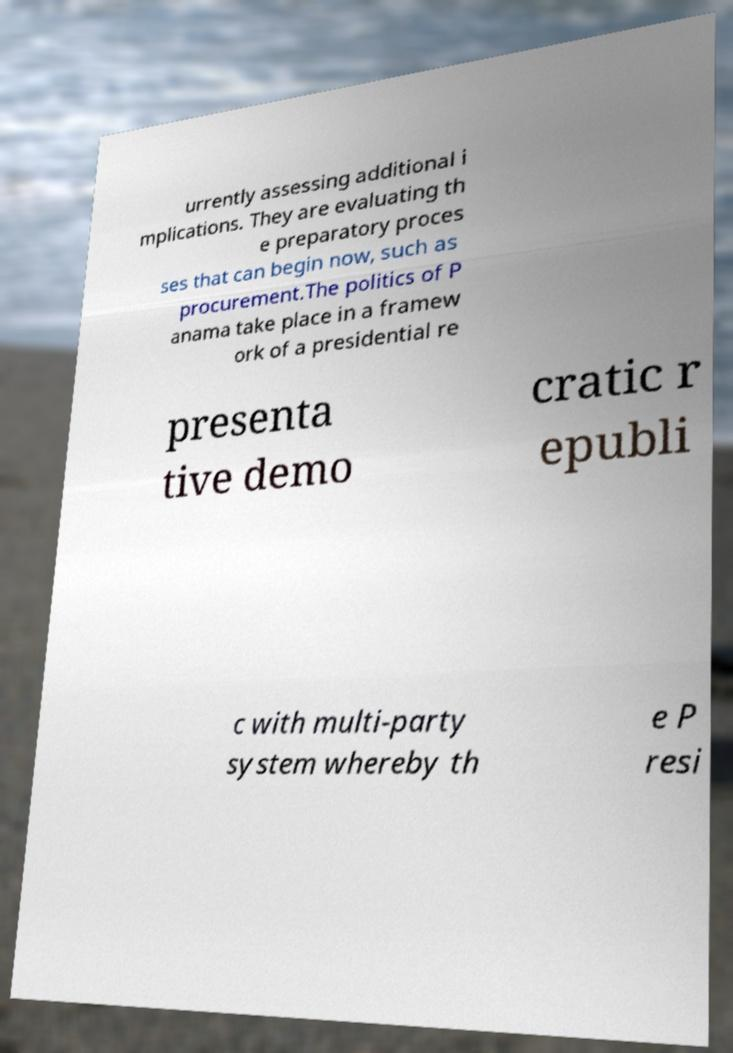There's text embedded in this image that I need extracted. Can you transcribe it verbatim? urrently assessing additional i mplications. They are evaluating th e preparatory proces ses that can begin now, such as procurement.The politics of P anama take place in a framew ork of a presidential re presenta tive demo cratic r epubli c with multi-party system whereby th e P resi 